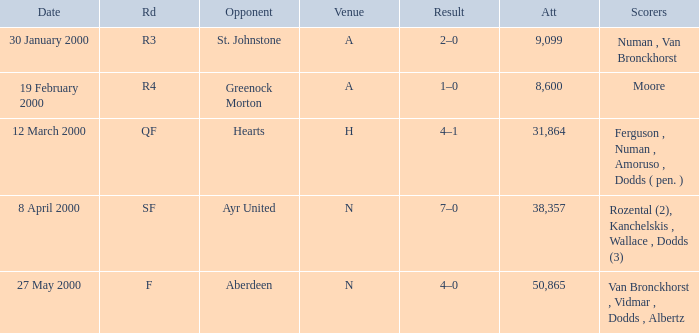Who was on 12 March 2000? Ferguson , Numan , Amoruso , Dodds ( pen. ). 